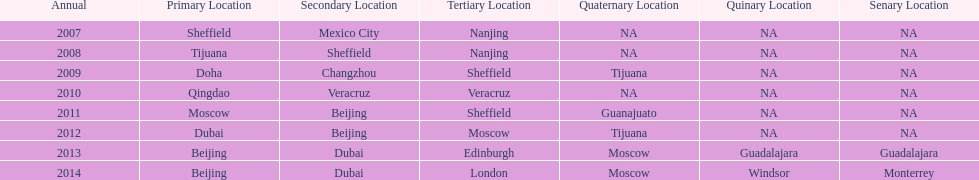Which is the only year that mexico is on a venue 2007. 